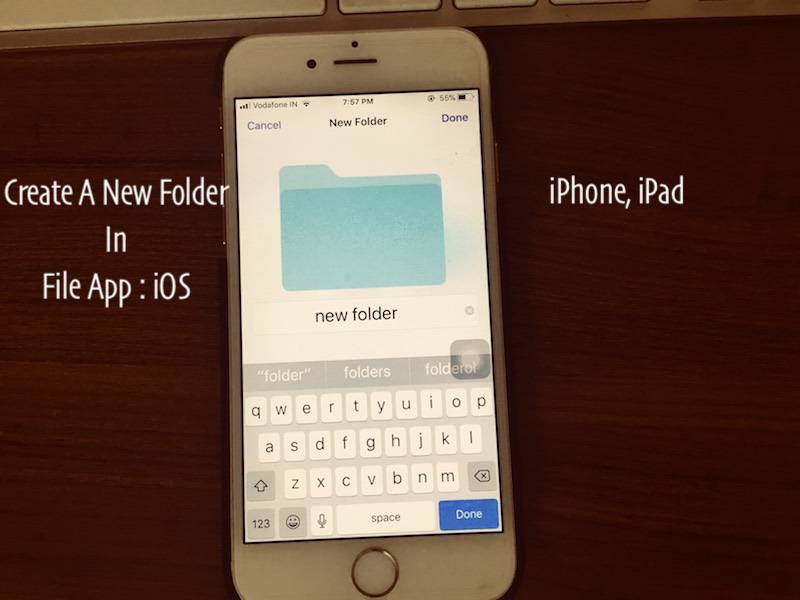How might the user benefit from creating new folders in the File app at this time of day when the battery is at 56%? Creating new folders in the File app at this time of day can help the user enhance their productivity and organization for the following day. By structuring files into dedicated folders, the user could reduce the time needed to search for documents or media files, thereby improving their efficiency. Additionally, organizing their files before the device runs low on battery ensures that they won’t be interrupted by the need to charge the device immediately. This habit can also contribute to better digital hygiene, making it easier to maintain and locate important files when needed. 